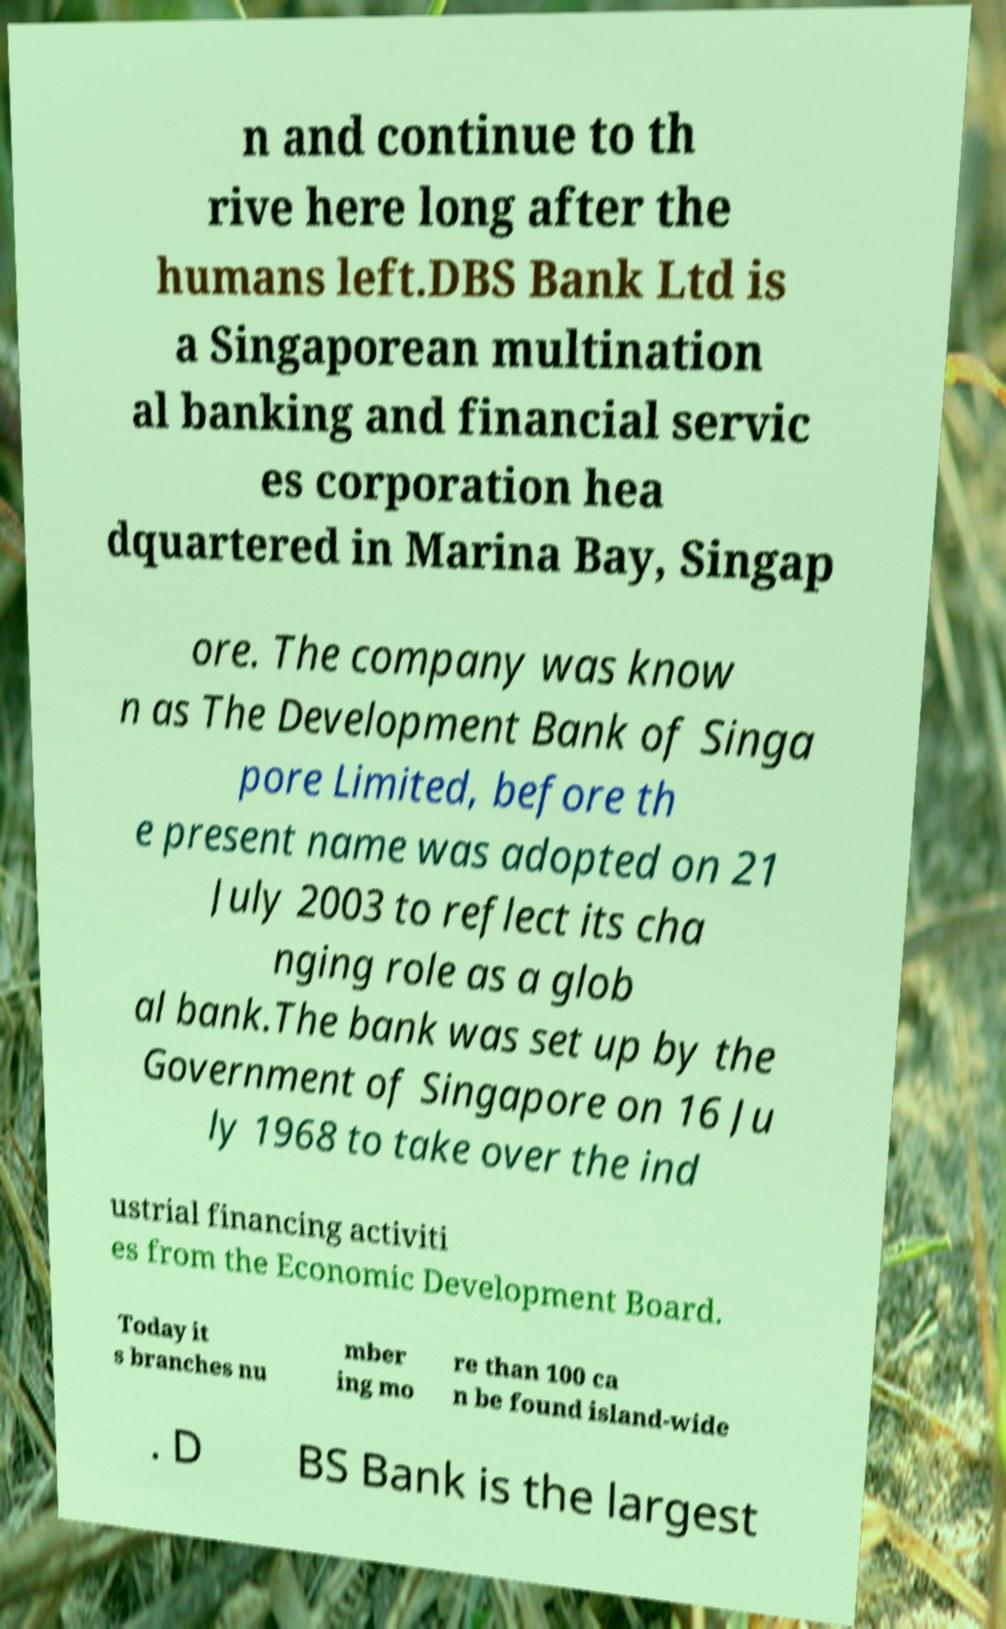Can you accurately transcribe the text from the provided image for me? n and continue to th rive here long after the humans left.DBS Bank Ltd is a Singaporean multination al banking and financial servic es corporation hea dquartered in Marina Bay, Singap ore. The company was know n as The Development Bank of Singa pore Limited, before th e present name was adopted on 21 July 2003 to reflect its cha nging role as a glob al bank.The bank was set up by the Government of Singapore on 16 Ju ly 1968 to take over the ind ustrial financing activiti es from the Economic Development Board. Today it s branches nu mber ing mo re than 100 ca n be found island-wide . D BS Bank is the largest 